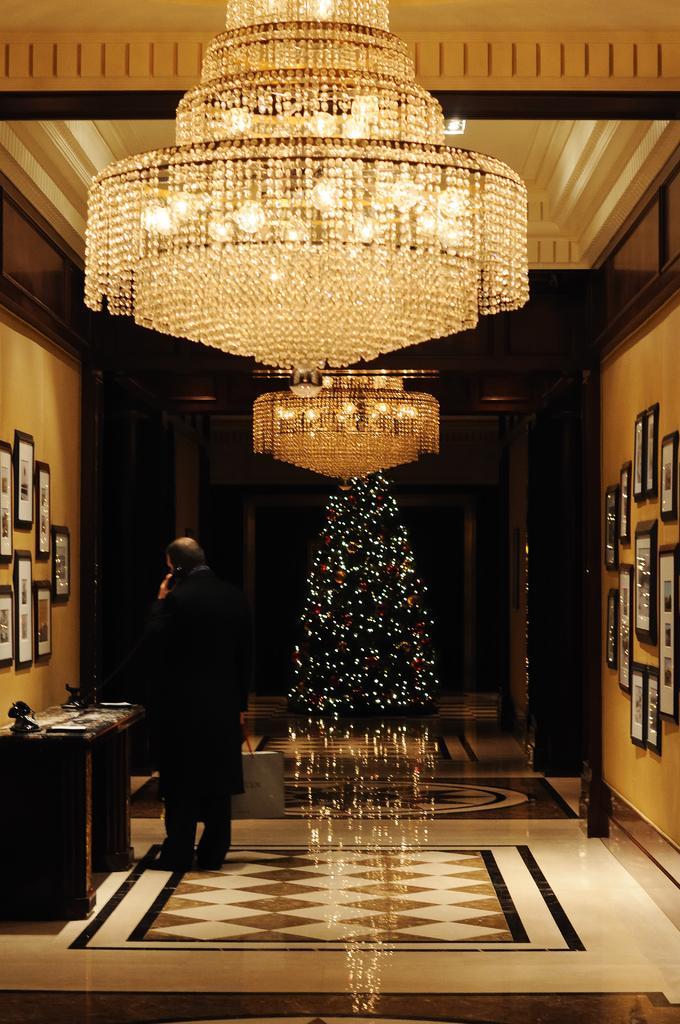Can you describe this image briefly? In this image I can see a man is standing and holding a telephone handle. On these walls I can see number of frames. Here I can see lights. 